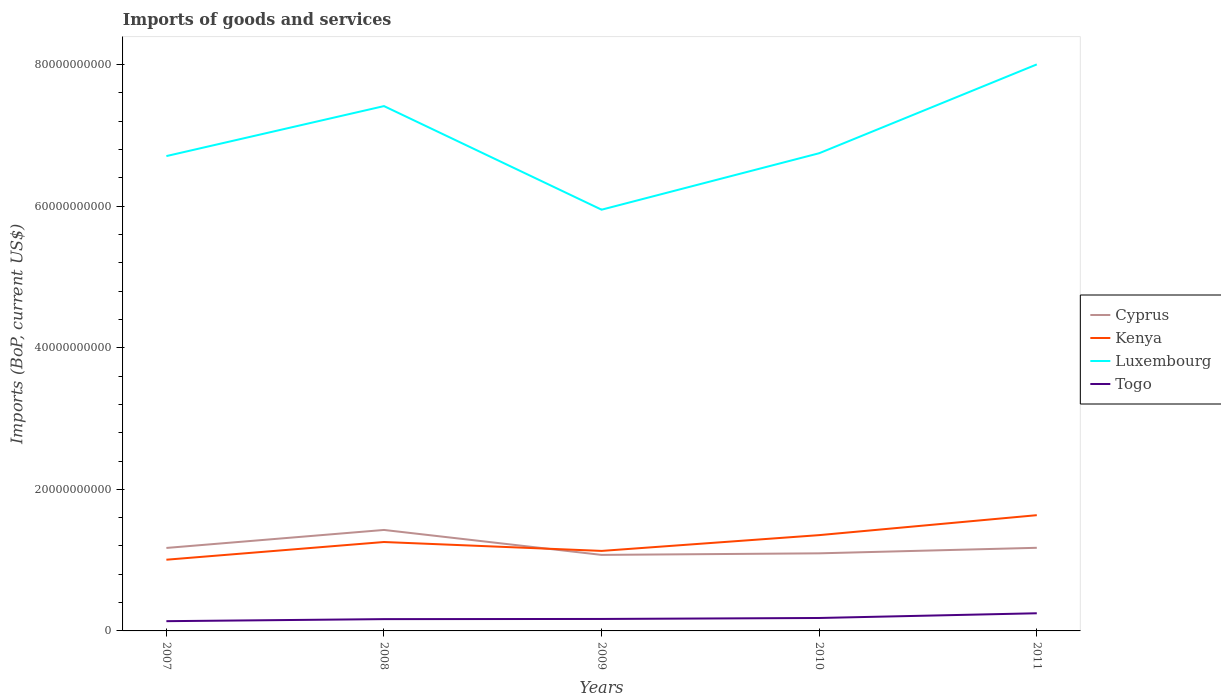Is the number of lines equal to the number of legend labels?
Keep it short and to the point. Yes. Across all years, what is the maximum amount spent on imports in Cyprus?
Offer a terse response. 1.07e+1. What is the total amount spent on imports in Kenya in the graph?
Make the answer very short. -3.47e+09. What is the difference between the highest and the second highest amount spent on imports in Kenya?
Make the answer very short. 6.29e+09. How many lines are there?
Keep it short and to the point. 4. How many years are there in the graph?
Make the answer very short. 5. How many legend labels are there?
Make the answer very short. 4. How are the legend labels stacked?
Make the answer very short. Vertical. What is the title of the graph?
Keep it short and to the point. Imports of goods and services. What is the label or title of the X-axis?
Your answer should be compact. Years. What is the label or title of the Y-axis?
Your answer should be very brief. Imports (BoP, current US$). What is the Imports (BoP, current US$) of Cyprus in 2007?
Ensure brevity in your answer.  1.17e+1. What is the Imports (BoP, current US$) of Kenya in 2007?
Ensure brevity in your answer.  1.01e+1. What is the Imports (BoP, current US$) in Luxembourg in 2007?
Offer a terse response. 6.71e+1. What is the Imports (BoP, current US$) of Togo in 2007?
Provide a succinct answer. 1.38e+09. What is the Imports (BoP, current US$) in Cyprus in 2008?
Provide a short and direct response. 1.43e+1. What is the Imports (BoP, current US$) of Kenya in 2008?
Ensure brevity in your answer.  1.26e+1. What is the Imports (BoP, current US$) of Luxembourg in 2008?
Offer a terse response. 7.41e+1. What is the Imports (BoP, current US$) of Togo in 2008?
Your answer should be very brief. 1.67e+09. What is the Imports (BoP, current US$) in Cyprus in 2009?
Your answer should be compact. 1.07e+1. What is the Imports (BoP, current US$) of Kenya in 2009?
Offer a very short reply. 1.13e+1. What is the Imports (BoP, current US$) of Luxembourg in 2009?
Your answer should be compact. 5.95e+1. What is the Imports (BoP, current US$) in Togo in 2009?
Provide a succinct answer. 1.69e+09. What is the Imports (BoP, current US$) of Cyprus in 2010?
Ensure brevity in your answer.  1.10e+1. What is the Imports (BoP, current US$) of Kenya in 2010?
Provide a short and direct response. 1.35e+1. What is the Imports (BoP, current US$) in Luxembourg in 2010?
Your answer should be compact. 6.75e+1. What is the Imports (BoP, current US$) in Togo in 2010?
Keep it short and to the point. 1.83e+09. What is the Imports (BoP, current US$) in Cyprus in 2011?
Your answer should be very brief. 1.17e+1. What is the Imports (BoP, current US$) of Kenya in 2011?
Your answer should be very brief. 1.63e+1. What is the Imports (BoP, current US$) in Luxembourg in 2011?
Make the answer very short. 8.00e+1. What is the Imports (BoP, current US$) in Togo in 2011?
Provide a succinct answer. 2.49e+09. Across all years, what is the maximum Imports (BoP, current US$) of Cyprus?
Your answer should be compact. 1.43e+1. Across all years, what is the maximum Imports (BoP, current US$) in Kenya?
Offer a very short reply. 1.63e+1. Across all years, what is the maximum Imports (BoP, current US$) in Luxembourg?
Offer a very short reply. 8.00e+1. Across all years, what is the maximum Imports (BoP, current US$) of Togo?
Provide a short and direct response. 2.49e+09. Across all years, what is the minimum Imports (BoP, current US$) of Cyprus?
Keep it short and to the point. 1.07e+1. Across all years, what is the minimum Imports (BoP, current US$) in Kenya?
Ensure brevity in your answer.  1.01e+1. Across all years, what is the minimum Imports (BoP, current US$) in Luxembourg?
Provide a short and direct response. 5.95e+1. Across all years, what is the minimum Imports (BoP, current US$) in Togo?
Provide a short and direct response. 1.38e+09. What is the total Imports (BoP, current US$) of Cyprus in the graph?
Offer a terse response. 5.94e+1. What is the total Imports (BoP, current US$) in Kenya in the graph?
Provide a succinct answer. 6.38e+1. What is the total Imports (BoP, current US$) in Luxembourg in the graph?
Offer a terse response. 3.48e+11. What is the total Imports (BoP, current US$) in Togo in the graph?
Ensure brevity in your answer.  9.06e+09. What is the difference between the Imports (BoP, current US$) in Cyprus in 2007 and that in 2008?
Make the answer very short. -2.54e+09. What is the difference between the Imports (BoP, current US$) in Kenya in 2007 and that in 2008?
Give a very brief answer. -2.50e+09. What is the difference between the Imports (BoP, current US$) in Luxembourg in 2007 and that in 2008?
Your answer should be very brief. -7.06e+09. What is the difference between the Imports (BoP, current US$) in Togo in 2007 and that in 2008?
Your answer should be compact. -2.89e+08. What is the difference between the Imports (BoP, current US$) of Cyprus in 2007 and that in 2009?
Provide a succinct answer. 9.82e+08. What is the difference between the Imports (BoP, current US$) of Kenya in 2007 and that in 2009?
Ensure brevity in your answer.  -1.24e+09. What is the difference between the Imports (BoP, current US$) in Luxembourg in 2007 and that in 2009?
Your answer should be compact. 7.57e+09. What is the difference between the Imports (BoP, current US$) in Togo in 2007 and that in 2009?
Your response must be concise. -3.12e+08. What is the difference between the Imports (BoP, current US$) in Cyprus in 2007 and that in 2010?
Make the answer very short. 7.60e+08. What is the difference between the Imports (BoP, current US$) of Kenya in 2007 and that in 2010?
Make the answer very short. -3.47e+09. What is the difference between the Imports (BoP, current US$) in Luxembourg in 2007 and that in 2010?
Make the answer very short. -4.05e+08. What is the difference between the Imports (BoP, current US$) in Togo in 2007 and that in 2010?
Provide a succinct answer. -4.51e+08. What is the difference between the Imports (BoP, current US$) in Cyprus in 2007 and that in 2011?
Your answer should be compact. -2.01e+07. What is the difference between the Imports (BoP, current US$) in Kenya in 2007 and that in 2011?
Make the answer very short. -6.29e+09. What is the difference between the Imports (BoP, current US$) in Luxembourg in 2007 and that in 2011?
Keep it short and to the point. -1.29e+1. What is the difference between the Imports (BoP, current US$) in Togo in 2007 and that in 2011?
Ensure brevity in your answer.  -1.12e+09. What is the difference between the Imports (BoP, current US$) in Cyprus in 2008 and that in 2009?
Provide a succinct answer. 3.52e+09. What is the difference between the Imports (BoP, current US$) in Kenya in 2008 and that in 2009?
Your answer should be very brief. 1.26e+09. What is the difference between the Imports (BoP, current US$) of Luxembourg in 2008 and that in 2009?
Give a very brief answer. 1.46e+1. What is the difference between the Imports (BoP, current US$) of Togo in 2008 and that in 2009?
Offer a very short reply. -2.35e+07. What is the difference between the Imports (BoP, current US$) in Cyprus in 2008 and that in 2010?
Your answer should be very brief. 3.30e+09. What is the difference between the Imports (BoP, current US$) of Kenya in 2008 and that in 2010?
Your response must be concise. -9.72e+08. What is the difference between the Imports (BoP, current US$) in Luxembourg in 2008 and that in 2010?
Ensure brevity in your answer.  6.66e+09. What is the difference between the Imports (BoP, current US$) of Togo in 2008 and that in 2010?
Your answer should be compact. -1.62e+08. What is the difference between the Imports (BoP, current US$) in Cyprus in 2008 and that in 2011?
Offer a very short reply. 2.52e+09. What is the difference between the Imports (BoP, current US$) in Kenya in 2008 and that in 2011?
Make the answer very short. -3.79e+09. What is the difference between the Imports (BoP, current US$) in Luxembourg in 2008 and that in 2011?
Ensure brevity in your answer.  -5.89e+09. What is the difference between the Imports (BoP, current US$) in Togo in 2008 and that in 2011?
Make the answer very short. -8.27e+08. What is the difference between the Imports (BoP, current US$) in Cyprus in 2009 and that in 2010?
Make the answer very short. -2.22e+08. What is the difference between the Imports (BoP, current US$) of Kenya in 2009 and that in 2010?
Give a very brief answer. -2.23e+09. What is the difference between the Imports (BoP, current US$) of Luxembourg in 2009 and that in 2010?
Offer a terse response. -7.98e+09. What is the difference between the Imports (BoP, current US$) in Togo in 2009 and that in 2010?
Keep it short and to the point. -1.38e+08. What is the difference between the Imports (BoP, current US$) in Cyprus in 2009 and that in 2011?
Keep it short and to the point. -1.00e+09. What is the difference between the Imports (BoP, current US$) of Kenya in 2009 and that in 2011?
Provide a succinct answer. -5.05e+09. What is the difference between the Imports (BoP, current US$) of Luxembourg in 2009 and that in 2011?
Your response must be concise. -2.05e+1. What is the difference between the Imports (BoP, current US$) of Togo in 2009 and that in 2011?
Give a very brief answer. -8.03e+08. What is the difference between the Imports (BoP, current US$) of Cyprus in 2010 and that in 2011?
Make the answer very short. -7.80e+08. What is the difference between the Imports (BoP, current US$) of Kenya in 2010 and that in 2011?
Offer a very short reply. -2.82e+09. What is the difference between the Imports (BoP, current US$) of Luxembourg in 2010 and that in 2011?
Provide a succinct answer. -1.25e+1. What is the difference between the Imports (BoP, current US$) of Togo in 2010 and that in 2011?
Ensure brevity in your answer.  -6.65e+08. What is the difference between the Imports (BoP, current US$) of Cyprus in 2007 and the Imports (BoP, current US$) of Kenya in 2008?
Ensure brevity in your answer.  -8.38e+08. What is the difference between the Imports (BoP, current US$) of Cyprus in 2007 and the Imports (BoP, current US$) of Luxembourg in 2008?
Give a very brief answer. -6.24e+1. What is the difference between the Imports (BoP, current US$) in Cyprus in 2007 and the Imports (BoP, current US$) in Togo in 2008?
Provide a succinct answer. 1.01e+1. What is the difference between the Imports (BoP, current US$) of Kenya in 2007 and the Imports (BoP, current US$) of Luxembourg in 2008?
Give a very brief answer. -6.41e+1. What is the difference between the Imports (BoP, current US$) in Kenya in 2007 and the Imports (BoP, current US$) in Togo in 2008?
Keep it short and to the point. 8.39e+09. What is the difference between the Imports (BoP, current US$) in Luxembourg in 2007 and the Imports (BoP, current US$) in Togo in 2008?
Provide a succinct answer. 6.54e+1. What is the difference between the Imports (BoP, current US$) of Cyprus in 2007 and the Imports (BoP, current US$) of Kenya in 2009?
Ensure brevity in your answer.  4.19e+08. What is the difference between the Imports (BoP, current US$) in Cyprus in 2007 and the Imports (BoP, current US$) in Luxembourg in 2009?
Make the answer very short. -4.78e+1. What is the difference between the Imports (BoP, current US$) in Cyprus in 2007 and the Imports (BoP, current US$) in Togo in 2009?
Your answer should be compact. 1.00e+1. What is the difference between the Imports (BoP, current US$) of Kenya in 2007 and the Imports (BoP, current US$) of Luxembourg in 2009?
Your answer should be very brief. -4.94e+1. What is the difference between the Imports (BoP, current US$) in Kenya in 2007 and the Imports (BoP, current US$) in Togo in 2009?
Provide a short and direct response. 8.37e+09. What is the difference between the Imports (BoP, current US$) of Luxembourg in 2007 and the Imports (BoP, current US$) of Togo in 2009?
Keep it short and to the point. 6.54e+1. What is the difference between the Imports (BoP, current US$) in Cyprus in 2007 and the Imports (BoP, current US$) in Kenya in 2010?
Offer a very short reply. -1.81e+09. What is the difference between the Imports (BoP, current US$) of Cyprus in 2007 and the Imports (BoP, current US$) of Luxembourg in 2010?
Give a very brief answer. -5.58e+1. What is the difference between the Imports (BoP, current US$) of Cyprus in 2007 and the Imports (BoP, current US$) of Togo in 2010?
Offer a terse response. 9.89e+09. What is the difference between the Imports (BoP, current US$) of Kenya in 2007 and the Imports (BoP, current US$) of Luxembourg in 2010?
Offer a very short reply. -5.74e+1. What is the difference between the Imports (BoP, current US$) of Kenya in 2007 and the Imports (BoP, current US$) of Togo in 2010?
Your answer should be very brief. 8.23e+09. What is the difference between the Imports (BoP, current US$) of Luxembourg in 2007 and the Imports (BoP, current US$) of Togo in 2010?
Make the answer very short. 6.52e+1. What is the difference between the Imports (BoP, current US$) in Cyprus in 2007 and the Imports (BoP, current US$) in Kenya in 2011?
Your response must be concise. -4.63e+09. What is the difference between the Imports (BoP, current US$) in Cyprus in 2007 and the Imports (BoP, current US$) in Luxembourg in 2011?
Offer a very short reply. -6.83e+1. What is the difference between the Imports (BoP, current US$) in Cyprus in 2007 and the Imports (BoP, current US$) in Togo in 2011?
Make the answer very short. 9.23e+09. What is the difference between the Imports (BoP, current US$) of Kenya in 2007 and the Imports (BoP, current US$) of Luxembourg in 2011?
Keep it short and to the point. -7.00e+1. What is the difference between the Imports (BoP, current US$) in Kenya in 2007 and the Imports (BoP, current US$) in Togo in 2011?
Make the answer very short. 7.57e+09. What is the difference between the Imports (BoP, current US$) in Luxembourg in 2007 and the Imports (BoP, current US$) in Togo in 2011?
Provide a succinct answer. 6.46e+1. What is the difference between the Imports (BoP, current US$) in Cyprus in 2008 and the Imports (BoP, current US$) in Kenya in 2009?
Your answer should be compact. 2.96e+09. What is the difference between the Imports (BoP, current US$) of Cyprus in 2008 and the Imports (BoP, current US$) of Luxembourg in 2009?
Make the answer very short. -4.52e+1. What is the difference between the Imports (BoP, current US$) in Cyprus in 2008 and the Imports (BoP, current US$) in Togo in 2009?
Make the answer very short. 1.26e+1. What is the difference between the Imports (BoP, current US$) in Kenya in 2008 and the Imports (BoP, current US$) in Luxembourg in 2009?
Give a very brief answer. -4.69e+1. What is the difference between the Imports (BoP, current US$) of Kenya in 2008 and the Imports (BoP, current US$) of Togo in 2009?
Offer a terse response. 1.09e+1. What is the difference between the Imports (BoP, current US$) in Luxembourg in 2008 and the Imports (BoP, current US$) in Togo in 2009?
Provide a short and direct response. 7.24e+1. What is the difference between the Imports (BoP, current US$) in Cyprus in 2008 and the Imports (BoP, current US$) in Kenya in 2010?
Provide a short and direct response. 7.32e+08. What is the difference between the Imports (BoP, current US$) in Cyprus in 2008 and the Imports (BoP, current US$) in Luxembourg in 2010?
Keep it short and to the point. -5.32e+1. What is the difference between the Imports (BoP, current US$) of Cyprus in 2008 and the Imports (BoP, current US$) of Togo in 2010?
Offer a terse response. 1.24e+1. What is the difference between the Imports (BoP, current US$) in Kenya in 2008 and the Imports (BoP, current US$) in Luxembourg in 2010?
Your answer should be compact. -5.49e+1. What is the difference between the Imports (BoP, current US$) of Kenya in 2008 and the Imports (BoP, current US$) of Togo in 2010?
Provide a succinct answer. 1.07e+1. What is the difference between the Imports (BoP, current US$) in Luxembourg in 2008 and the Imports (BoP, current US$) in Togo in 2010?
Ensure brevity in your answer.  7.23e+1. What is the difference between the Imports (BoP, current US$) in Cyprus in 2008 and the Imports (BoP, current US$) in Kenya in 2011?
Provide a succinct answer. -2.09e+09. What is the difference between the Imports (BoP, current US$) in Cyprus in 2008 and the Imports (BoP, current US$) in Luxembourg in 2011?
Your answer should be compact. -6.58e+1. What is the difference between the Imports (BoP, current US$) in Cyprus in 2008 and the Imports (BoP, current US$) in Togo in 2011?
Provide a short and direct response. 1.18e+1. What is the difference between the Imports (BoP, current US$) of Kenya in 2008 and the Imports (BoP, current US$) of Luxembourg in 2011?
Your response must be concise. -6.75e+1. What is the difference between the Imports (BoP, current US$) in Kenya in 2008 and the Imports (BoP, current US$) in Togo in 2011?
Give a very brief answer. 1.01e+1. What is the difference between the Imports (BoP, current US$) of Luxembourg in 2008 and the Imports (BoP, current US$) of Togo in 2011?
Keep it short and to the point. 7.16e+1. What is the difference between the Imports (BoP, current US$) in Cyprus in 2009 and the Imports (BoP, current US$) in Kenya in 2010?
Give a very brief answer. -2.79e+09. What is the difference between the Imports (BoP, current US$) in Cyprus in 2009 and the Imports (BoP, current US$) in Luxembourg in 2010?
Provide a short and direct response. -5.67e+1. What is the difference between the Imports (BoP, current US$) in Cyprus in 2009 and the Imports (BoP, current US$) in Togo in 2010?
Offer a terse response. 8.91e+09. What is the difference between the Imports (BoP, current US$) in Kenya in 2009 and the Imports (BoP, current US$) in Luxembourg in 2010?
Make the answer very short. -5.62e+1. What is the difference between the Imports (BoP, current US$) of Kenya in 2009 and the Imports (BoP, current US$) of Togo in 2010?
Provide a succinct answer. 9.47e+09. What is the difference between the Imports (BoP, current US$) in Luxembourg in 2009 and the Imports (BoP, current US$) in Togo in 2010?
Your response must be concise. 5.77e+1. What is the difference between the Imports (BoP, current US$) in Cyprus in 2009 and the Imports (BoP, current US$) in Kenya in 2011?
Provide a short and direct response. -5.61e+09. What is the difference between the Imports (BoP, current US$) of Cyprus in 2009 and the Imports (BoP, current US$) of Luxembourg in 2011?
Your response must be concise. -6.93e+1. What is the difference between the Imports (BoP, current US$) in Cyprus in 2009 and the Imports (BoP, current US$) in Togo in 2011?
Offer a very short reply. 8.25e+09. What is the difference between the Imports (BoP, current US$) in Kenya in 2009 and the Imports (BoP, current US$) in Luxembourg in 2011?
Your answer should be very brief. -6.87e+1. What is the difference between the Imports (BoP, current US$) of Kenya in 2009 and the Imports (BoP, current US$) of Togo in 2011?
Your answer should be very brief. 8.81e+09. What is the difference between the Imports (BoP, current US$) in Luxembourg in 2009 and the Imports (BoP, current US$) in Togo in 2011?
Give a very brief answer. 5.70e+1. What is the difference between the Imports (BoP, current US$) of Cyprus in 2010 and the Imports (BoP, current US$) of Kenya in 2011?
Your response must be concise. -5.39e+09. What is the difference between the Imports (BoP, current US$) of Cyprus in 2010 and the Imports (BoP, current US$) of Luxembourg in 2011?
Provide a succinct answer. -6.91e+1. What is the difference between the Imports (BoP, current US$) of Cyprus in 2010 and the Imports (BoP, current US$) of Togo in 2011?
Ensure brevity in your answer.  8.47e+09. What is the difference between the Imports (BoP, current US$) in Kenya in 2010 and the Imports (BoP, current US$) in Luxembourg in 2011?
Ensure brevity in your answer.  -6.65e+1. What is the difference between the Imports (BoP, current US$) of Kenya in 2010 and the Imports (BoP, current US$) of Togo in 2011?
Make the answer very short. 1.10e+1. What is the difference between the Imports (BoP, current US$) of Luxembourg in 2010 and the Imports (BoP, current US$) of Togo in 2011?
Your answer should be very brief. 6.50e+1. What is the average Imports (BoP, current US$) in Cyprus per year?
Ensure brevity in your answer.  1.19e+1. What is the average Imports (BoP, current US$) of Kenya per year?
Give a very brief answer. 1.28e+1. What is the average Imports (BoP, current US$) of Luxembourg per year?
Offer a terse response. 6.96e+1. What is the average Imports (BoP, current US$) in Togo per year?
Your answer should be very brief. 1.81e+09. In the year 2007, what is the difference between the Imports (BoP, current US$) of Cyprus and Imports (BoP, current US$) of Kenya?
Your answer should be compact. 1.66e+09. In the year 2007, what is the difference between the Imports (BoP, current US$) in Cyprus and Imports (BoP, current US$) in Luxembourg?
Your answer should be compact. -5.54e+1. In the year 2007, what is the difference between the Imports (BoP, current US$) of Cyprus and Imports (BoP, current US$) of Togo?
Make the answer very short. 1.03e+1. In the year 2007, what is the difference between the Imports (BoP, current US$) in Kenya and Imports (BoP, current US$) in Luxembourg?
Give a very brief answer. -5.70e+1. In the year 2007, what is the difference between the Imports (BoP, current US$) in Kenya and Imports (BoP, current US$) in Togo?
Your response must be concise. 8.68e+09. In the year 2007, what is the difference between the Imports (BoP, current US$) in Luxembourg and Imports (BoP, current US$) in Togo?
Make the answer very short. 6.57e+1. In the year 2008, what is the difference between the Imports (BoP, current US$) in Cyprus and Imports (BoP, current US$) in Kenya?
Your answer should be very brief. 1.70e+09. In the year 2008, what is the difference between the Imports (BoP, current US$) of Cyprus and Imports (BoP, current US$) of Luxembourg?
Your answer should be compact. -5.99e+1. In the year 2008, what is the difference between the Imports (BoP, current US$) in Cyprus and Imports (BoP, current US$) in Togo?
Your answer should be compact. 1.26e+1. In the year 2008, what is the difference between the Imports (BoP, current US$) of Kenya and Imports (BoP, current US$) of Luxembourg?
Offer a very short reply. -6.16e+1. In the year 2008, what is the difference between the Imports (BoP, current US$) of Kenya and Imports (BoP, current US$) of Togo?
Offer a terse response. 1.09e+1. In the year 2008, what is the difference between the Imports (BoP, current US$) of Luxembourg and Imports (BoP, current US$) of Togo?
Your response must be concise. 7.25e+1. In the year 2009, what is the difference between the Imports (BoP, current US$) of Cyprus and Imports (BoP, current US$) of Kenya?
Give a very brief answer. -5.62e+08. In the year 2009, what is the difference between the Imports (BoP, current US$) of Cyprus and Imports (BoP, current US$) of Luxembourg?
Keep it short and to the point. -4.88e+1. In the year 2009, what is the difference between the Imports (BoP, current US$) of Cyprus and Imports (BoP, current US$) of Togo?
Your answer should be very brief. 9.05e+09. In the year 2009, what is the difference between the Imports (BoP, current US$) of Kenya and Imports (BoP, current US$) of Luxembourg?
Make the answer very short. -4.82e+1. In the year 2009, what is the difference between the Imports (BoP, current US$) in Kenya and Imports (BoP, current US$) in Togo?
Keep it short and to the point. 9.61e+09. In the year 2009, what is the difference between the Imports (BoP, current US$) of Luxembourg and Imports (BoP, current US$) of Togo?
Give a very brief answer. 5.78e+1. In the year 2010, what is the difference between the Imports (BoP, current US$) of Cyprus and Imports (BoP, current US$) of Kenya?
Your answer should be very brief. -2.57e+09. In the year 2010, what is the difference between the Imports (BoP, current US$) of Cyprus and Imports (BoP, current US$) of Luxembourg?
Your answer should be very brief. -5.65e+1. In the year 2010, what is the difference between the Imports (BoP, current US$) of Cyprus and Imports (BoP, current US$) of Togo?
Provide a short and direct response. 9.13e+09. In the year 2010, what is the difference between the Imports (BoP, current US$) of Kenya and Imports (BoP, current US$) of Luxembourg?
Give a very brief answer. -5.39e+1. In the year 2010, what is the difference between the Imports (BoP, current US$) of Kenya and Imports (BoP, current US$) of Togo?
Your answer should be compact. 1.17e+1. In the year 2010, what is the difference between the Imports (BoP, current US$) in Luxembourg and Imports (BoP, current US$) in Togo?
Your answer should be compact. 6.56e+1. In the year 2011, what is the difference between the Imports (BoP, current US$) of Cyprus and Imports (BoP, current US$) of Kenya?
Your answer should be compact. -4.61e+09. In the year 2011, what is the difference between the Imports (BoP, current US$) of Cyprus and Imports (BoP, current US$) of Luxembourg?
Your answer should be very brief. -6.83e+1. In the year 2011, what is the difference between the Imports (BoP, current US$) in Cyprus and Imports (BoP, current US$) in Togo?
Provide a succinct answer. 9.25e+09. In the year 2011, what is the difference between the Imports (BoP, current US$) in Kenya and Imports (BoP, current US$) in Luxembourg?
Your response must be concise. -6.37e+1. In the year 2011, what is the difference between the Imports (BoP, current US$) of Kenya and Imports (BoP, current US$) of Togo?
Offer a terse response. 1.39e+1. In the year 2011, what is the difference between the Imports (BoP, current US$) in Luxembourg and Imports (BoP, current US$) in Togo?
Offer a terse response. 7.75e+1. What is the ratio of the Imports (BoP, current US$) in Cyprus in 2007 to that in 2008?
Offer a very short reply. 0.82. What is the ratio of the Imports (BoP, current US$) in Kenya in 2007 to that in 2008?
Provide a succinct answer. 0.8. What is the ratio of the Imports (BoP, current US$) in Luxembourg in 2007 to that in 2008?
Make the answer very short. 0.9. What is the ratio of the Imports (BoP, current US$) in Togo in 2007 to that in 2008?
Offer a very short reply. 0.83. What is the ratio of the Imports (BoP, current US$) of Cyprus in 2007 to that in 2009?
Keep it short and to the point. 1.09. What is the ratio of the Imports (BoP, current US$) of Kenya in 2007 to that in 2009?
Offer a very short reply. 0.89. What is the ratio of the Imports (BoP, current US$) of Luxembourg in 2007 to that in 2009?
Offer a terse response. 1.13. What is the ratio of the Imports (BoP, current US$) of Togo in 2007 to that in 2009?
Provide a short and direct response. 0.82. What is the ratio of the Imports (BoP, current US$) in Cyprus in 2007 to that in 2010?
Provide a succinct answer. 1.07. What is the ratio of the Imports (BoP, current US$) of Kenya in 2007 to that in 2010?
Provide a short and direct response. 0.74. What is the ratio of the Imports (BoP, current US$) in Luxembourg in 2007 to that in 2010?
Offer a very short reply. 0.99. What is the ratio of the Imports (BoP, current US$) of Togo in 2007 to that in 2010?
Give a very brief answer. 0.75. What is the ratio of the Imports (BoP, current US$) of Cyprus in 2007 to that in 2011?
Make the answer very short. 1. What is the ratio of the Imports (BoP, current US$) of Kenya in 2007 to that in 2011?
Ensure brevity in your answer.  0.62. What is the ratio of the Imports (BoP, current US$) of Luxembourg in 2007 to that in 2011?
Keep it short and to the point. 0.84. What is the ratio of the Imports (BoP, current US$) of Togo in 2007 to that in 2011?
Offer a very short reply. 0.55. What is the ratio of the Imports (BoP, current US$) in Cyprus in 2008 to that in 2009?
Your response must be concise. 1.33. What is the ratio of the Imports (BoP, current US$) of Kenya in 2008 to that in 2009?
Make the answer very short. 1.11. What is the ratio of the Imports (BoP, current US$) in Luxembourg in 2008 to that in 2009?
Keep it short and to the point. 1.25. What is the ratio of the Imports (BoP, current US$) of Togo in 2008 to that in 2009?
Your response must be concise. 0.99. What is the ratio of the Imports (BoP, current US$) in Cyprus in 2008 to that in 2010?
Keep it short and to the point. 1.3. What is the ratio of the Imports (BoP, current US$) of Kenya in 2008 to that in 2010?
Offer a very short reply. 0.93. What is the ratio of the Imports (BoP, current US$) in Luxembourg in 2008 to that in 2010?
Provide a succinct answer. 1.1. What is the ratio of the Imports (BoP, current US$) in Togo in 2008 to that in 2010?
Keep it short and to the point. 0.91. What is the ratio of the Imports (BoP, current US$) in Cyprus in 2008 to that in 2011?
Your response must be concise. 1.21. What is the ratio of the Imports (BoP, current US$) of Kenya in 2008 to that in 2011?
Keep it short and to the point. 0.77. What is the ratio of the Imports (BoP, current US$) in Luxembourg in 2008 to that in 2011?
Your answer should be compact. 0.93. What is the ratio of the Imports (BoP, current US$) of Togo in 2008 to that in 2011?
Offer a very short reply. 0.67. What is the ratio of the Imports (BoP, current US$) of Cyprus in 2009 to that in 2010?
Provide a succinct answer. 0.98. What is the ratio of the Imports (BoP, current US$) in Kenya in 2009 to that in 2010?
Your answer should be very brief. 0.84. What is the ratio of the Imports (BoP, current US$) in Luxembourg in 2009 to that in 2010?
Offer a terse response. 0.88. What is the ratio of the Imports (BoP, current US$) of Togo in 2009 to that in 2010?
Provide a succinct answer. 0.92. What is the ratio of the Imports (BoP, current US$) in Cyprus in 2009 to that in 2011?
Your answer should be very brief. 0.91. What is the ratio of the Imports (BoP, current US$) of Kenya in 2009 to that in 2011?
Your response must be concise. 0.69. What is the ratio of the Imports (BoP, current US$) of Luxembourg in 2009 to that in 2011?
Your response must be concise. 0.74. What is the ratio of the Imports (BoP, current US$) in Togo in 2009 to that in 2011?
Offer a terse response. 0.68. What is the ratio of the Imports (BoP, current US$) of Cyprus in 2010 to that in 2011?
Provide a succinct answer. 0.93. What is the ratio of the Imports (BoP, current US$) in Kenya in 2010 to that in 2011?
Provide a succinct answer. 0.83. What is the ratio of the Imports (BoP, current US$) of Luxembourg in 2010 to that in 2011?
Make the answer very short. 0.84. What is the ratio of the Imports (BoP, current US$) in Togo in 2010 to that in 2011?
Give a very brief answer. 0.73. What is the difference between the highest and the second highest Imports (BoP, current US$) in Cyprus?
Keep it short and to the point. 2.52e+09. What is the difference between the highest and the second highest Imports (BoP, current US$) in Kenya?
Provide a succinct answer. 2.82e+09. What is the difference between the highest and the second highest Imports (BoP, current US$) of Luxembourg?
Your answer should be very brief. 5.89e+09. What is the difference between the highest and the second highest Imports (BoP, current US$) in Togo?
Offer a very short reply. 6.65e+08. What is the difference between the highest and the lowest Imports (BoP, current US$) in Cyprus?
Your response must be concise. 3.52e+09. What is the difference between the highest and the lowest Imports (BoP, current US$) in Kenya?
Provide a short and direct response. 6.29e+09. What is the difference between the highest and the lowest Imports (BoP, current US$) in Luxembourg?
Your answer should be compact. 2.05e+1. What is the difference between the highest and the lowest Imports (BoP, current US$) in Togo?
Your response must be concise. 1.12e+09. 